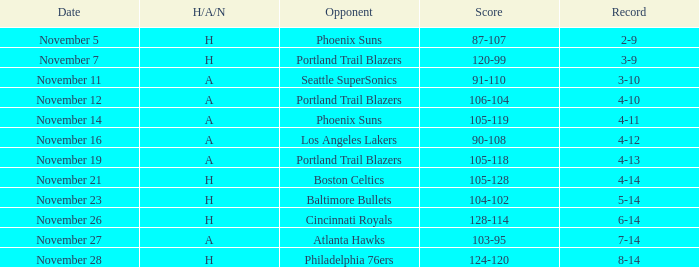On what Date was the Score 105-128? November 21. 